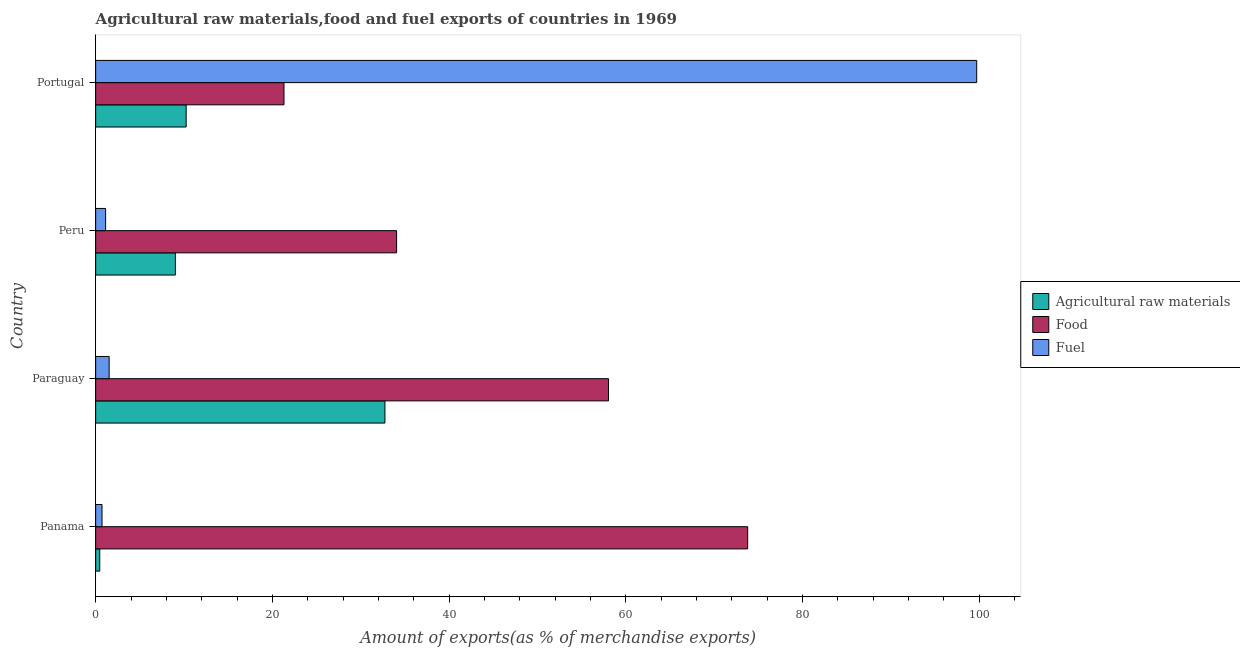How many groups of bars are there?
Provide a short and direct response. 4. What is the label of the 1st group of bars from the top?
Provide a succinct answer. Portugal. In how many cases, is the number of bars for a given country not equal to the number of legend labels?
Make the answer very short. 0. What is the percentage of fuel exports in Portugal?
Give a very brief answer. 99.72. Across all countries, what is the maximum percentage of food exports?
Offer a very short reply. 73.8. Across all countries, what is the minimum percentage of food exports?
Provide a short and direct response. 21.32. In which country was the percentage of raw materials exports maximum?
Offer a very short reply. Paraguay. In which country was the percentage of fuel exports minimum?
Offer a very short reply. Panama. What is the total percentage of raw materials exports in the graph?
Give a very brief answer. 52.47. What is the difference between the percentage of fuel exports in Paraguay and that in Peru?
Make the answer very short. 0.4. What is the difference between the percentage of food exports in Paraguay and the percentage of fuel exports in Peru?
Offer a terse response. 56.92. What is the average percentage of food exports per country?
Your answer should be very brief. 46.81. What is the difference between the percentage of fuel exports and percentage of food exports in Paraguay?
Provide a succinct answer. -56.52. What is the ratio of the percentage of raw materials exports in Paraguay to that in Portugal?
Keep it short and to the point. 3.2. Is the percentage of fuel exports in Paraguay less than that in Portugal?
Make the answer very short. Yes. Is the difference between the percentage of fuel exports in Paraguay and Portugal greater than the difference between the percentage of raw materials exports in Paraguay and Portugal?
Offer a terse response. No. What is the difference between the highest and the second highest percentage of raw materials exports?
Offer a very short reply. 22.5. What is the difference between the highest and the lowest percentage of raw materials exports?
Your response must be concise. 32.28. Is the sum of the percentage of raw materials exports in Panama and Peru greater than the maximum percentage of fuel exports across all countries?
Offer a terse response. No. What does the 2nd bar from the top in Paraguay represents?
Your answer should be very brief. Food. What does the 1st bar from the bottom in Portugal represents?
Give a very brief answer. Agricultural raw materials. Are all the bars in the graph horizontal?
Offer a terse response. Yes. How many countries are there in the graph?
Offer a terse response. 4. Where does the legend appear in the graph?
Your response must be concise. Center right. How are the legend labels stacked?
Offer a terse response. Vertical. What is the title of the graph?
Your response must be concise. Agricultural raw materials,food and fuel exports of countries in 1969. Does "Taxes" appear as one of the legend labels in the graph?
Provide a short and direct response. No. What is the label or title of the X-axis?
Your answer should be very brief. Amount of exports(as % of merchandise exports). What is the Amount of exports(as % of merchandise exports) in Agricultural raw materials in Panama?
Give a very brief answer. 0.46. What is the Amount of exports(as % of merchandise exports) of Food in Panama?
Give a very brief answer. 73.8. What is the Amount of exports(as % of merchandise exports) of Fuel in Panama?
Offer a very short reply. 0.72. What is the Amount of exports(as % of merchandise exports) in Agricultural raw materials in Paraguay?
Your answer should be compact. 32.74. What is the Amount of exports(as % of merchandise exports) in Food in Paraguay?
Your answer should be compact. 58.05. What is the Amount of exports(as % of merchandise exports) in Fuel in Paraguay?
Provide a succinct answer. 1.53. What is the Amount of exports(as % of merchandise exports) in Agricultural raw materials in Peru?
Offer a terse response. 9.02. What is the Amount of exports(as % of merchandise exports) of Food in Peru?
Give a very brief answer. 34.06. What is the Amount of exports(as % of merchandise exports) of Fuel in Peru?
Give a very brief answer. 1.13. What is the Amount of exports(as % of merchandise exports) in Agricultural raw materials in Portugal?
Your response must be concise. 10.24. What is the Amount of exports(as % of merchandise exports) in Food in Portugal?
Provide a short and direct response. 21.32. What is the Amount of exports(as % of merchandise exports) in Fuel in Portugal?
Keep it short and to the point. 99.72. Across all countries, what is the maximum Amount of exports(as % of merchandise exports) of Agricultural raw materials?
Your response must be concise. 32.74. Across all countries, what is the maximum Amount of exports(as % of merchandise exports) in Food?
Offer a very short reply. 73.8. Across all countries, what is the maximum Amount of exports(as % of merchandise exports) of Fuel?
Offer a terse response. 99.72. Across all countries, what is the minimum Amount of exports(as % of merchandise exports) in Agricultural raw materials?
Offer a very short reply. 0.46. Across all countries, what is the minimum Amount of exports(as % of merchandise exports) of Food?
Give a very brief answer. 21.32. Across all countries, what is the minimum Amount of exports(as % of merchandise exports) of Fuel?
Keep it short and to the point. 0.72. What is the total Amount of exports(as % of merchandise exports) in Agricultural raw materials in the graph?
Your response must be concise. 52.47. What is the total Amount of exports(as % of merchandise exports) in Food in the graph?
Provide a succinct answer. 187.23. What is the total Amount of exports(as % of merchandise exports) of Fuel in the graph?
Provide a short and direct response. 103.09. What is the difference between the Amount of exports(as % of merchandise exports) of Agricultural raw materials in Panama and that in Paraguay?
Your answer should be compact. -32.28. What is the difference between the Amount of exports(as % of merchandise exports) in Food in Panama and that in Paraguay?
Provide a succinct answer. 15.76. What is the difference between the Amount of exports(as % of merchandise exports) in Fuel in Panama and that in Paraguay?
Ensure brevity in your answer.  -0.81. What is the difference between the Amount of exports(as % of merchandise exports) in Agricultural raw materials in Panama and that in Peru?
Give a very brief answer. -8.56. What is the difference between the Amount of exports(as % of merchandise exports) in Food in Panama and that in Peru?
Your answer should be compact. 39.74. What is the difference between the Amount of exports(as % of merchandise exports) of Fuel in Panama and that in Peru?
Give a very brief answer. -0.41. What is the difference between the Amount of exports(as % of merchandise exports) in Agricultural raw materials in Panama and that in Portugal?
Make the answer very short. -9.78. What is the difference between the Amount of exports(as % of merchandise exports) of Food in Panama and that in Portugal?
Offer a terse response. 52.49. What is the difference between the Amount of exports(as % of merchandise exports) of Fuel in Panama and that in Portugal?
Make the answer very short. -99.01. What is the difference between the Amount of exports(as % of merchandise exports) of Agricultural raw materials in Paraguay and that in Peru?
Give a very brief answer. 23.72. What is the difference between the Amount of exports(as % of merchandise exports) in Food in Paraguay and that in Peru?
Your answer should be compact. 23.98. What is the difference between the Amount of exports(as % of merchandise exports) in Fuel in Paraguay and that in Peru?
Your answer should be very brief. 0.4. What is the difference between the Amount of exports(as % of merchandise exports) in Agricultural raw materials in Paraguay and that in Portugal?
Give a very brief answer. 22.5. What is the difference between the Amount of exports(as % of merchandise exports) of Food in Paraguay and that in Portugal?
Offer a very short reply. 36.73. What is the difference between the Amount of exports(as % of merchandise exports) in Fuel in Paraguay and that in Portugal?
Your answer should be compact. -98.2. What is the difference between the Amount of exports(as % of merchandise exports) in Agricultural raw materials in Peru and that in Portugal?
Keep it short and to the point. -1.22. What is the difference between the Amount of exports(as % of merchandise exports) in Food in Peru and that in Portugal?
Make the answer very short. 12.75. What is the difference between the Amount of exports(as % of merchandise exports) of Fuel in Peru and that in Portugal?
Offer a very short reply. -98.6. What is the difference between the Amount of exports(as % of merchandise exports) in Agricultural raw materials in Panama and the Amount of exports(as % of merchandise exports) in Food in Paraguay?
Make the answer very short. -57.58. What is the difference between the Amount of exports(as % of merchandise exports) in Agricultural raw materials in Panama and the Amount of exports(as % of merchandise exports) in Fuel in Paraguay?
Give a very brief answer. -1.06. What is the difference between the Amount of exports(as % of merchandise exports) in Food in Panama and the Amount of exports(as % of merchandise exports) in Fuel in Paraguay?
Provide a succinct answer. 72.28. What is the difference between the Amount of exports(as % of merchandise exports) in Agricultural raw materials in Panama and the Amount of exports(as % of merchandise exports) in Food in Peru?
Keep it short and to the point. -33.6. What is the difference between the Amount of exports(as % of merchandise exports) in Agricultural raw materials in Panama and the Amount of exports(as % of merchandise exports) in Fuel in Peru?
Keep it short and to the point. -0.66. What is the difference between the Amount of exports(as % of merchandise exports) in Food in Panama and the Amount of exports(as % of merchandise exports) in Fuel in Peru?
Your response must be concise. 72.68. What is the difference between the Amount of exports(as % of merchandise exports) in Agricultural raw materials in Panama and the Amount of exports(as % of merchandise exports) in Food in Portugal?
Offer a very short reply. -20.85. What is the difference between the Amount of exports(as % of merchandise exports) of Agricultural raw materials in Panama and the Amount of exports(as % of merchandise exports) of Fuel in Portugal?
Your answer should be compact. -99.26. What is the difference between the Amount of exports(as % of merchandise exports) in Food in Panama and the Amount of exports(as % of merchandise exports) in Fuel in Portugal?
Your answer should be very brief. -25.92. What is the difference between the Amount of exports(as % of merchandise exports) in Agricultural raw materials in Paraguay and the Amount of exports(as % of merchandise exports) in Food in Peru?
Offer a terse response. -1.32. What is the difference between the Amount of exports(as % of merchandise exports) in Agricultural raw materials in Paraguay and the Amount of exports(as % of merchandise exports) in Fuel in Peru?
Offer a very short reply. 31.62. What is the difference between the Amount of exports(as % of merchandise exports) of Food in Paraguay and the Amount of exports(as % of merchandise exports) of Fuel in Peru?
Offer a terse response. 56.92. What is the difference between the Amount of exports(as % of merchandise exports) of Agricultural raw materials in Paraguay and the Amount of exports(as % of merchandise exports) of Food in Portugal?
Offer a very short reply. 11.43. What is the difference between the Amount of exports(as % of merchandise exports) in Agricultural raw materials in Paraguay and the Amount of exports(as % of merchandise exports) in Fuel in Portugal?
Make the answer very short. -66.98. What is the difference between the Amount of exports(as % of merchandise exports) in Food in Paraguay and the Amount of exports(as % of merchandise exports) in Fuel in Portugal?
Provide a succinct answer. -41.68. What is the difference between the Amount of exports(as % of merchandise exports) of Agricultural raw materials in Peru and the Amount of exports(as % of merchandise exports) of Food in Portugal?
Ensure brevity in your answer.  -12.29. What is the difference between the Amount of exports(as % of merchandise exports) in Agricultural raw materials in Peru and the Amount of exports(as % of merchandise exports) in Fuel in Portugal?
Provide a short and direct response. -90.7. What is the difference between the Amount of exports(as % of merchandise exports) of Food in Peru and the Amount of exports(as % of merchandise exports) of Fuel in Portugal?
Offer a very short reply. -65.66. What is the average Amount of exports(as % of merchandise exports) of Agricultural raw materials per country?
Keep it short and to the point. 13.12. What is the average Amount of exports(as % of merchandise exports) of Food per country?
Provide a short and direct response. 46.81. What is the average Amount of exports(as % of merchandise exports) in Fuel per country?
Ensure brevity in your answer.  25.77. What is the difference between the Amount of exports(as % of merchandise exports) of Agricultural raw materials and Amount of exports(as % of merchandise exports) of Food in Panama?
Offer a terse response. -73.34. What is the difference between the Amount of exports(as % of merchandise exports) in Agricultural raw materials and Amount of exports(as % of merchandise exports) in Fuel in Panama?
Ensure brevity in your answer.  -0.26. What is the difference between the Amount of exports(as % of merchandise exports) in Food and Amount of exports(as % of merchandise exports) in Fuel in Panama?
Make the answer very short. 73.08. What is the difference between the Amount of exports(as % of merchandise exports) in Agricultural raw materials and Amount of exports(as % of merchandise exports) in Food in Paraguay?
Your answer should be compact. -25.3. What is the difference between the Amount of exports(as % of merchandise exports) in Agricultural raw materials and Amount of exports(as % of merchandise exports) in Fuel in Paraguay?
Offer a terse response. 31.22. What is the difference between the Amount of exports(as % of merchandise exports) of Food and Amount of exports(as % of merchandise exports) of Fuel in Paraguay?
Provide a short and direct response. 56.52. What is the difference between the Amount of exports(as % of merchandise exports) of Agricultural raw materials and Amount of exports(as % of merchandise exports) of Food in Peru?
Offer a very short reply. -25.04. What is the difference between the Amount of exports(as % of merchandise exports) in Agricultural raw materials and Amount of exports(as % of merchandise exports) in Fuel in Peru?
Provide a succinct answer. 7.9. What is the difference between the Amount of exports(as % of merchandise exports) of Food and Amount of exports(as % of merchandise exports) of Fuel in Peru?
Make the answer very short. 32.94. What is the difference between the Amount of exports(as % of merchandise exports) in Agricultural raw materials and Amount of exports(as % of merchandise exports) in Food in Portugal?
Provide a succinct answer. -11.07. What is the difference between the Amount of exports(as % of merchandise exports) of Agricultural raw materials and Amount of exports(as % of merchandise exports) of Fuel in Portugal?
Make the answer very short. -89.48. What is the difference between the Amount of exports(as % of merchandise exports) in Food and Amount of exports(as % of merchandise exports) in Fuel in Portugal?
Provide a succinct answer. -78.41. What is the ratio of the Amount of exports(as % of merchandise exports) in Agricultural raw materials in Panama to that in Paraguay?
Give a very brief answer. 0.01. What is the ratio of the Amount of exports(as % of merchandise exports) of Food in Panama to that in Paraguay?
Provide a succinct answer. 1.27. What is the ratio of the Amount of exports(as % of merchandise exports) of Fuel in Panama to that in Paraguay?
Give a very brief answer. 0.47. What is the ratio of the Amount of exports(as % of merchandise exports) of Agricultural raw materials in Panama to that in Peru?
Provide a succinct answer. 0.05. What is the ratio of the Amount of exports(as % of merchandise exports) of Food in Panama to that in Peru?
Your answer should be compact. 2.17. What is the ratio of the Amount of exports(as % of merchandise exports) in Fuel in Panama to that in Peru?
Provide a succinct answer. 0.64. What is the ratio of the Amount of exports(as % of merchandise exports) in Agricultural raw materials in Panama to that in Portugal?
Provide a succinct answer. 0.05. What is the ratio of the Amount of exports(as % of merchandise exports) of Food in Panama to that in Portugal?
Keep it short and to the point. 3.46. What is the ratio of the Amount of exports(as % of merchandise exports) in Fuel in Panama to that in Portugal?
Your answer should be compact. 0.01. What is the ratio of the Amount of exports(as % of merchandise exports) of Agricultural raw materials in Paraguay to that in Peru?
Keep it short and to the point. 3.63. What is the ratio of the Amount of exports(as % of merchandise exports) in Food in Paraguay to that in Peru?
Your answer should be compact. 1.7. What is the ratio of the Amount of exports(as % of merchandise exports) in Fuel in Paraguay to that in Peru?
Give a very brief answer. 1.35. What is the ratio of the Amount of exports(as % of merchandise exports) of Agricultural raw materials in Paraguay to that in Portugal?
Make the answer very short. 3.2. What is the ratio of the Amount of exports(as % of merchandise exports) of Food in Paraguay to that in Portugal?
Ensure brevity in your answer.  2.72. What is the ratio of the Amount of exports(as % of merchandise exports) in Fuel in Paraguay to that in Portugal?
Your response must be concise. 0.02. What is the ratio of the Amount of exports(as % of merchandise exports) of Agricultural raw materials in Peru to that in Portugal?
Your response must be concise. 0.88. What is the ratio of the Amount of exports(as % of merchandise exports) of Food in Peru to that in Portugal?
Your response must be concise. 1.6. What is the ratio of the Amount of exports(as % of merchandise exports) of Fuel in Peru to that in Portugal?
Provide a succinct answer. 0.01. What is the difference between the highest and the second highest Amount of exports(as % of merchandise exports) in Agricultural raw materials?
Offer a very short reply. 22.5. What is the difference between the highest and the second highest Amount of exports(as % of merchandise exports) of Food?
Give a very brief answer. 15.76. What is the difference between the highest and the second highest Amount of exports(as % of merchandise exports) of Fuel?
Your answer should be very brief. 98.2. What is the difference between the highest and the lowest Amount of exports(as % of merchandise exports) in Agricultural raw materials?
Give a very brief answer. 32.28. What is the difference between the highest and the lowest Amount of exports(as % of merchandise exports) of Food?
Make the answer very short. 52.49. What is the difference between the highest and the lowest Amount of exports(as % of merchandise exports) of Fuel?
Ensure brevity in your answer.  99.01. 